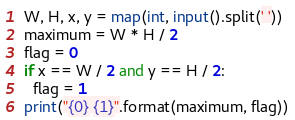Convert code to text. <code><loc_0><loc_0><loc_500><loc_500><_Python_>W, H, x, y = map(int, input().split(' '))
maximum = W * H / 2
flag = 0
if x == W / 2 and y == H / 2:
  flag = 1
print("{0} {1}".format(maximum, flag))</code> 